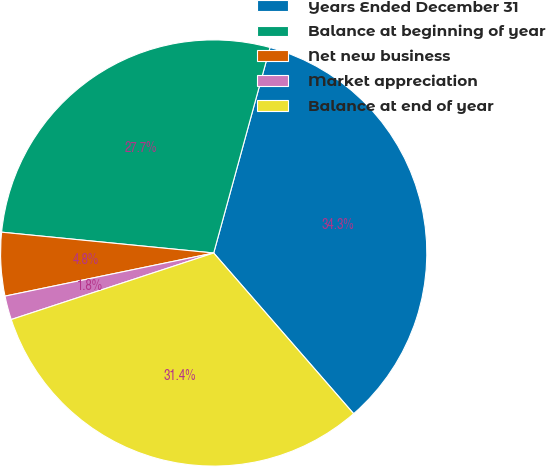<chart> <loc_0><loc_0><loc_500><loc_500><pie_chart><fcel>Years Ended December 31<fcel>Balance at beginning of year<fcel>Net new business<fcel>Market appreciation<fcel>Balance at end of year<nl><fcel>34.34%<fcel>27.7%<fcel>4.8%<fcel>1.81%<fcel>31.35%<nl></chart> 